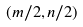<formula> <loc_0><loc_0><loc_500><loc_500>( m / 2 , n / 2 )</formula> 